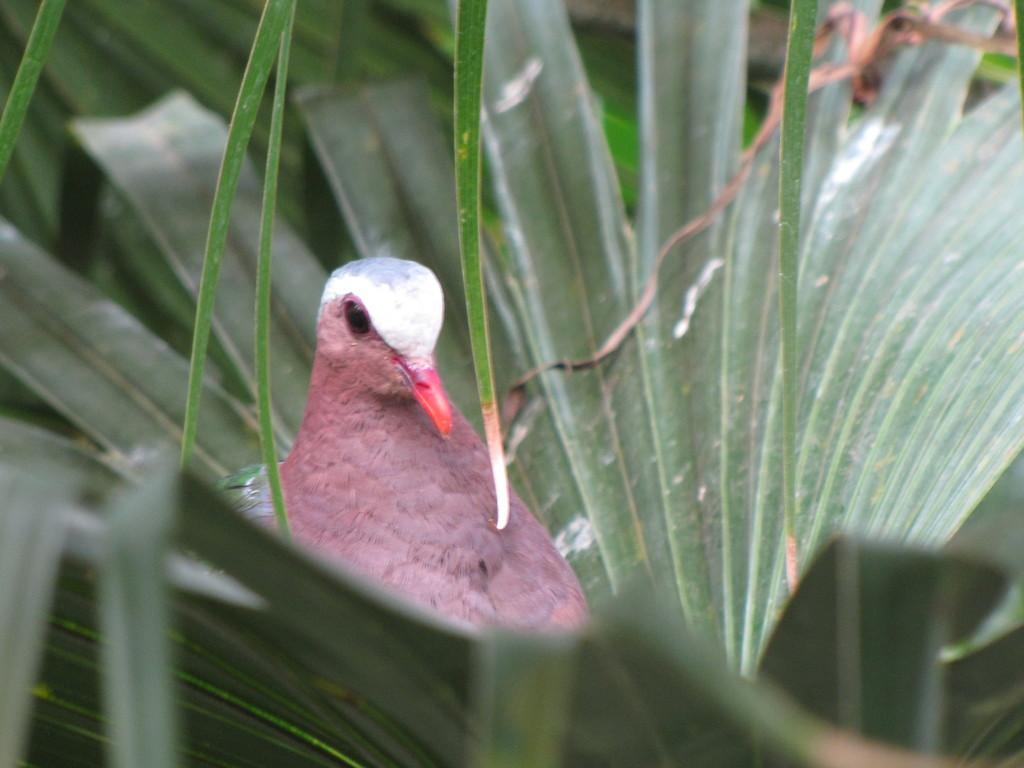What animal is present in the image? There is a pigeon in the picture. What is surrounding the pigeon in the image? There are leaves around the pigeon. Can you describe the background of the image? The backdrop of the image is blurred. What type of underwear is the pigeon wearing in the image? Pigeons do not wear underwear, so this detail cannot be found in the image. 